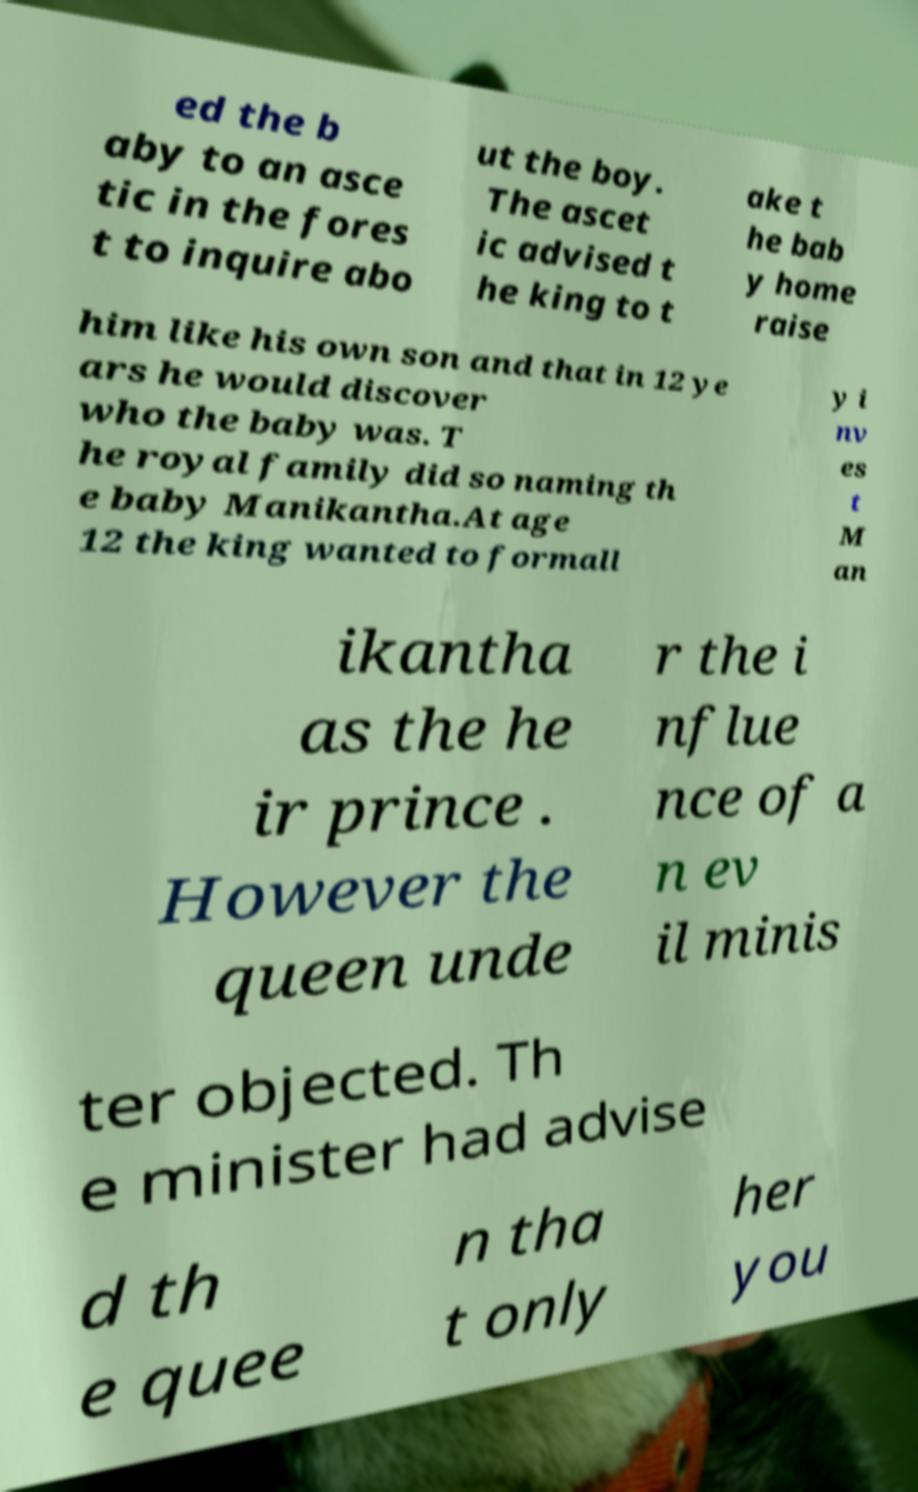I need the written content from this picture converted into text. Can you do that? ed the b aby to an asce tic in the fores t to inquire abo ut the boy. The ascet ic advised t he king to t ake t he bab y home raise him like his own son and that in 12 ye ars he would discover who the baby was. T he royal family did so naming th e baby Manikantha.At age 12 the king wanted to formall y i nv es t M an ikantha as the he ir prince . However the queen unde r the i nflue nce of a n ev il minis ter objected. Th e minister had advise d th e quee n tha t only her you 